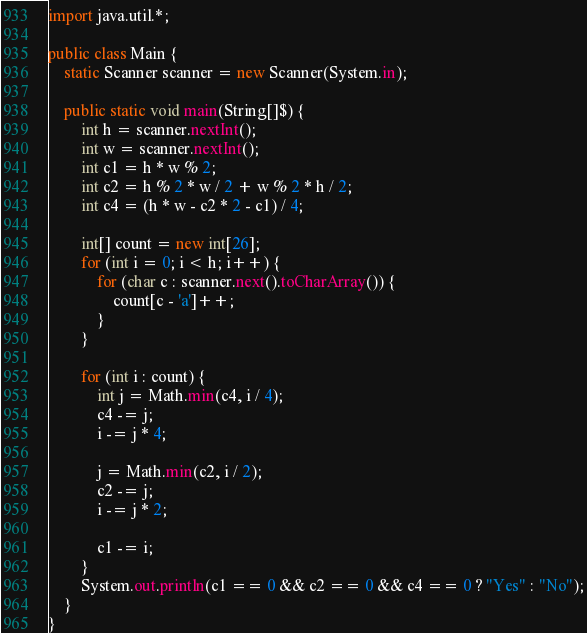<code> <loc_0><loc_0><loc_500><loc_500><_Java_>import java.util.*;

public class Main {
    static Scanner scanner = new Scanner(System.in);

    public static void main(String[]$) {
        int h = scanner.nextInt();
        int w = scanner.nextInt();
        int c1 = h * w % 2;
        int c2 = h % 2 * w / 2 + w % 2 * h / 2;
        int c4 = (h * w - c2 * 2 - c1) / 4;

        int[] count = new int[26];
        for (int i = 0; i < h; i++) {
            for (char c : scanner.next().toCharArray()) {
                count[c - 'a']++;
            }
        }

        for (int i : count) {
            int j = Math.min(c4, i / 4);
            c4 -= j;
            i -= j * 4;

            j = Math.min(c2, i / 2);
            c2 -= j;
            i -= j * 2;

            c1 -= i;
        }
        System.out.println(c1 == 0 && c2 == 0 && c4 == 0 ? "Yes" : "No");
    }
}</code> 